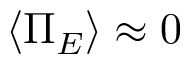<formula> <loc_0><loc_0><loc_500><loc_500>\langle \Pi _ { E } \rangle \approx 0</formula> 